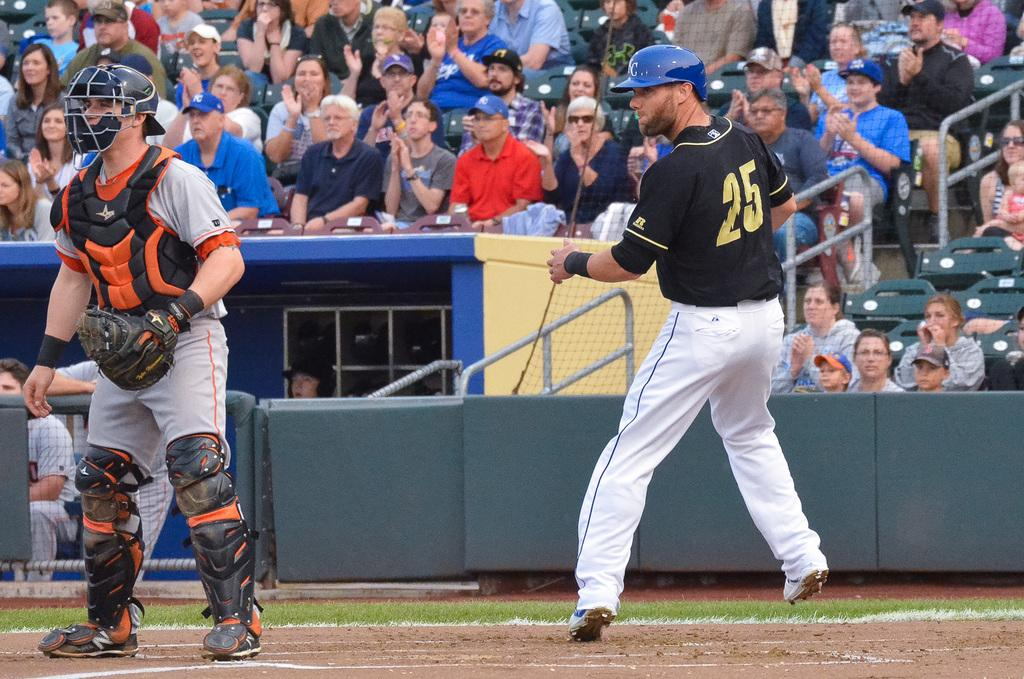How many baseball players are in the image? There are two baseball players in the image. Where are the baseball players located? The baseball players are on a ground. What is behind the baseball players? There is a fencing behind the baseball players. What can be seen beyond the fencing? There is a crowd behind the fencing. What type of farm animals can be seen on the table in the image? There is no table or farm animals present in the image. 